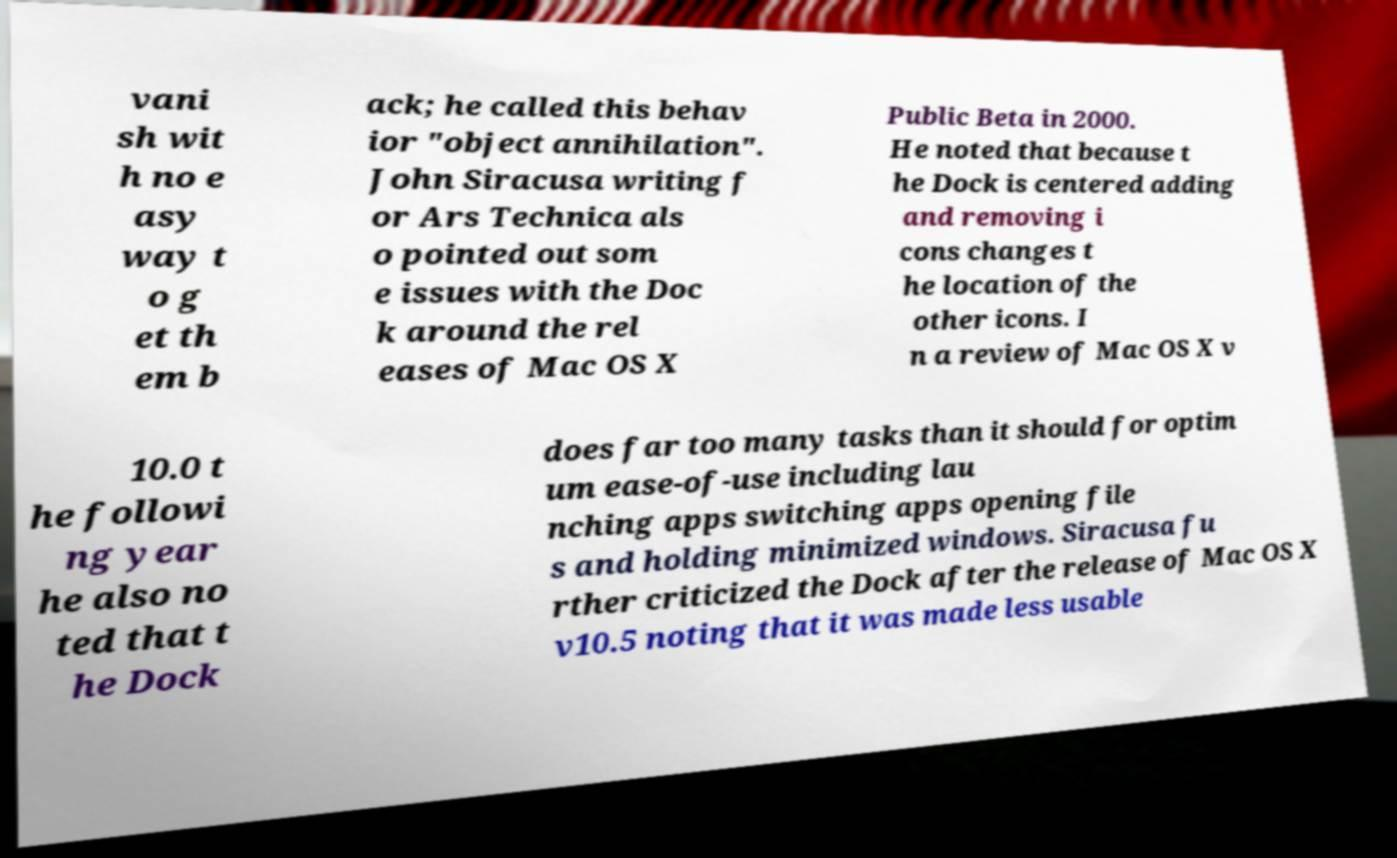Can you accurately transcribe the text from the provided image for me? vani sh wit h no e asy way t o g et th em b ack; he called this behav ior "object annihilation". John Siracusa writing f or Ars Technica als o pointed out som e issues with the Doc k around the rel eases of Mac OS X Public Beta in 2000. He noted that because t he Dock is centered adding and removing i cons changes t he location of the other icons. I n a review of Mac OS X v 10.0 t he followi ng year he also no ted that t he Dock does far too many tasks than it should for optim um ease-of-use including lau nching apps switching apps opening file s and holding minimized windows. Siracusa fu rther criticized the Dock after the release of Mac OS X v10.5 noting that it was made less usable 